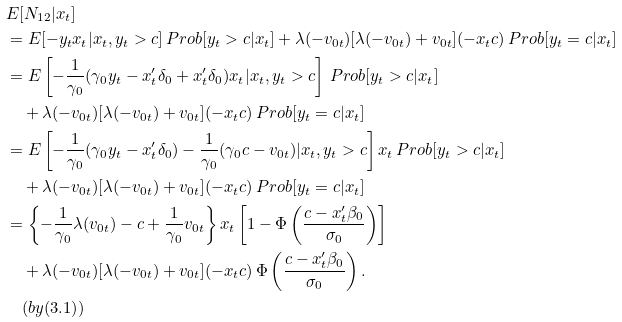Convert formula to latex. <formula><loc_0><loc_0><loc_500><loc_500>& E [ N _ { 1 2 } | x _ { t } ] \\ & = E [ - y _ { t } x _ { t } | x _ { t } , y _ { t } > c ] \, P r o b [ y _ { t } > c | x _ { t } ] + \lambda ( - v _ { 0 t } ) [ \lambda ( - v _ { 0 t } ) + v _ { 0 t } ] ( - x _ { t } c ) \, P r o b [ y _ { t } = c | x _ { t } ] \\ & = E \left [ - \frac { 1 } { \gamma _ { 0 } } ( \gamma _ { 0 } y _ { t } - x ^ { \prime } _ { t } \delta _ { 0 } + x ^ { \prime } _ { t } \delta _ { 0 } ) x _ { t } | x _ { t } , y _ { t } > c \right ] \, P r o b [ y _ { t } > c | x _ { t } ] \\ & \quad + \lambda ( - v _ { 0 t } ) [ \lambda ( - v _ { 0 t } ) + v _ { 0 t } ] ( - x _ { t } c ) \, P r o b [ y _ { t } = c | x _ { t } ] \\ & = E \left [ - \frac { 1 } { \gamma _ { 0 } } ( \gamma _ { 0 } y _ { t } - x ^ { \prime } _ { t } \delta _ { 0 } ) - \frac { 1 } { \gamma _ { 0 } } ( \gamma _ { 0 } c - v _ { 0 t } ) | x _ { t } , y _ { t } > c \right ] x _ { t } \, P r o b [ y _ { t } > c | x _ { t } ] \\ & \quad + \lambda ( - v _ { 0 t } ) [ \lambda ( - v _ { 0 t } ) + v _ { 0 t } ] ( - x _ { t } c ) \, P r o b [ y _ { t } = c | x _ { t } ] \\ & = \left \{ - \frac { 1 } { \gamma _ { 0 } } \lambda ( v _ { 0 t } ) - c + \frac { 1 } { \gamma _ { 0 } } v _ { 0 t } \right \} x _ { t } \left [ 1 - \Phi \left ( \frac { c - x ^ { \prime } _ { t } \beta _ { 0 } } { \sigma _ { 0 } } \right ) \right ] \\ & \quad + \lambda ( - v _ { 0 t } ) [ \lambda ( - v _ { 0 t } ) + v _ { 0 t } ] ( - x _ { t } c ) \, \Phi \left ( \frac { c - x ^ { \prime } _ { t } \beta _ { 0 } } { \sigma _ { 0 } } \right ) . \\ & \quad ( b y ( 3 . 1 ) )</formula> 